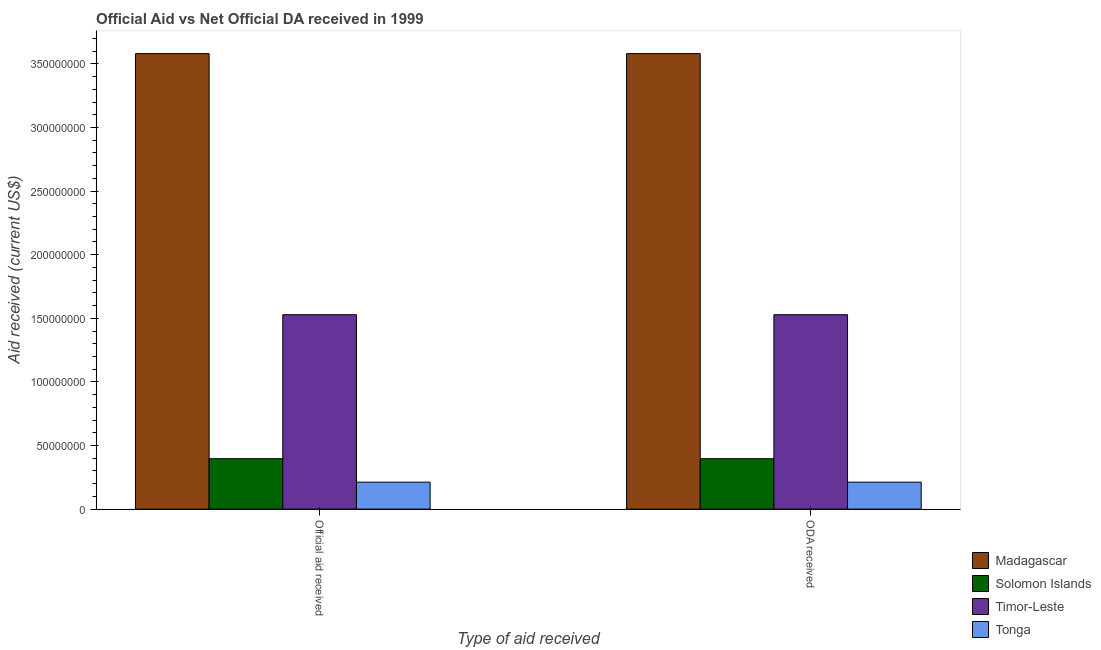How many bars are there on the 1st tick from the right?
Provide a short and direct response. 4. What is the label of the 1st group of bars from the left?
Your response must be concise. Official aid received. What is the oda received in Tonga?
Give a very brief answer. 2.12e+07. Across all countries, what is the maximum oda received?
Provide a succinct answer. 3.58e+08. Across all countries, what is the minimum oda received?
Ensure brevity in your answer.  2.12e+07. In which country was the official aid received maximum?
Your answer should be compact. Madagascar. In which country was the oda received minimum?
Offer a terse response. Tonga. What is the total oda received in the graph?
Ensure brevity in your answer.  5.72e+08. What is the difference between the official aid received in Madagascar and that in Tonga?
Your response must be concise. 3.37e+08. What is the difference between the official aid received in Tonga and the oda received in Timor-Leste?
Make the answer very short. -1.32e+08. What is the average official aid received per country?
Offer a very short reply. 1.43e+08. What is the ratio of the official aid received in Timor-Leste to that in Tonga?
Ensure brevity in your answer.  7.21. Is the official aid received in Solomon Islands less than that in Tonga?
Make the answer very short. No. What does the 2nd bar from the left in ODA received represents?
Make the answer very short. Solomon Islands. What does the 1st bar from the right in Official aid received represents?
Keep it short and to the point. Tonga. How many bars are there?
Make the answer very short. 8. What is the title of the graph?
Provide a succinct answer. Official Aid vs Net Official DA received in 1999 . Does "Azerbaijan" appear as one of the legend labels in the graph?
Keep it short and to the point. No. What is the label or title of the X-axis?
Keep it short and to the point. Type of aid received. What is the label or title of the Y-axis?
Offer a very short reply. Aid received (current US$). What is the Aid received (current US$) in Madagascar in Official aid received?
Provide a short and direct response. 3.58e+08. What is the Aid received (current US$) of Solomon Islands in Official aid received?
Give a very brief answer. 3.96e+07. What is the Aid received (current US$) in Timor-Leste in Official aid received?
Your answer should be compact. 1.53e+08. What is the Aid received (current US$) in Tonga in Official aid received?
Your response must be concise. 2.12e+07. What is the Aid received (current US$) of Madagascar in ODA received?
Provide a succinct answer. 3.58e+08. What is the Aid received (current US$) in Solomon Islands in ODA received?
Offer a terse response. 3.96e+07. What is the Aid received (current US$) of Timor-Leste in ODA received?
Provide a succinct answer. 1.53e+08. What is the Aid received (current US$) in Tonga in ODA received?
Ensure brevity in your answer.  2.12e+07. Across all Type of aid received, what is the maximum Aid received (current US$) of Madagascar?
Your answer should be compact. 3.58e+08. Across all Type of aid received, what is the maximum Aid received (current US$) in Solomon Islands?
Give a very brief answer. 3.96e+07. Across all Type of aid received, what is the maximum Aid received (current US$) of Timor-Leste?
Provide a short and direct response. 1.53e+08. Across all Type of aid received, what is the maximum Aid received (current US$) of Tonga?
Ensure brevity in your answer.  2.12e+07. Across all Type of aid received, what is the minimum Aid received (current US$) in Madagascar?
Provide a short and direct response. 3.58e+08. Across all Type of aid received, what is the minimum Aid received (current US$) of Solomon Islands?
Offer a very short reply. 3.96e+07. Across all Type of aid received, what is the minimum Aid received (current US$) in Timor-Leste?
Make the answer very short. 1.53e+08. Across all Type of aid received, what is the minimum Aid received (current US$) of Tonga?
Your answer should be compact. 2.12e+07. What is the total Aid received (current US$) of Madagascar in the graph?
Your answer should be compact. 7.16e+08. What is the total Aid received (current US$) in Solomon Islands in the graph?
Provide a succinct answer. 7.93e+07. What is the total Aid received (current US$) of Timor-Leste in the graph?
Give a very brief answer. 3.06e+08. What is the total Aid received (current US$) of Tonga in the graph?
Make the answer very short. 4.24e+07. What is the difference between the Aid received (current US$) in Madagascar in Official aid received and that in ODA received?
Give a very brief answer. 0. What is the difference between the Aid received (current US$) of Solomon Islands in Official aid received and that in ODA received?
Make the answer very short. 0. What is the difference between the Aid received (current US$) in Tonga in Official aid received and that in ODA received?
Give a very brief answer. 0. What is the difference between the Aid received (current US$) of Madagascar in Official aid received and the Aid received (current US$) of Solomon Islands in ODA received?
Give a very brief answer. 3.18e+08. What is the difference between the Aid received (current US$) in Madagascar in Official aid received and the Aid received (current US$) in Timor-Leste in ODA received?
Offer a very short reply. 2.05e+08. What is the difference between the Aid received (current US$) of Madagascar in Official aid received and the Aid received (current US$) of Tonga in ODA received?
Your response must be concise. 3.37e+08. What is the difference between the Aid received (current US$) of Solomon Islands in Official aid received and the Aid received (current US$) of Timor-Leste in ODA received?
Your answer should be very brief. -1.13e+08. What is the difference between the Aid received (current US$) of Solomon Islands in Official aid received and the Aid received (current US$) of Tonga in ODA received?
Keep it short and to the point. 1.84e+07. What is the difference between the Aid received (current US$) in Timor-Leste in Official aid received and the Aid received (current US$) in Tonga in ODA received?
Make the answer very short. 1.32e+08. What is the average Aid received (current US$) of Madagascar per Type of aid received?
Ensure brevity in your answer.  3.58e+08. What is the average Aid received (current US$) in Solomon Islands per Type of aid received?
Provide a succinct answer. 3.96e+07. What is the average Aid received (current US$) in Timor-Leste per Type of aid received?
Provide a succinct answer. 1.53e+08. What is the average Aid received (current US$) of Tonga per Type of aid received?
Make the answer very short. 2.12e+07. What is the difference between the Aid received (current US$) of Madagascar and Aid received (current US$) of Solomon Islands in Official aid received?
Ensure brevity in your answer.  3.18e+08. What is the difference between the Aid received (current US$) in Madagascar and Aid received (current US$) in Timor-Leste in Official aid received?
Your answer should be compact. 2.05e+08. What is the difference between the Aid received (current US$) of Madagascar and Aid received (current US$) of Tonga in Official aid received?
Your answer should be very brief. 3.37e+08. What is the difference between the Aid received (current US$) in Solomon Islands and Aid received (current US$) in Timor-Leste in Official aid received?
Your response must be concise. -1.13e+08. What is the difference between the Aid received (current US$) of Solomon Islands and Aid received (current US$) of Tonga in Official aid received?
Give a very brief answer. 1.84e+07. What is the difference between the Aid received (current US$) of Timor-Leste and Aid received (current US$) of Tonga in Official aid received?
Give a very brief answer. 1.32e+08. What is the difference between the Aid received (current US$) of Madagascar and Aid received (current US$) of Solomon Islands in ODA received?
Make the answer very short. 3.18e+08. What is the difference between the Aid received (current US$) in Madagascar and Aid received (current US$) in Timor-Leste in ODA received?
Ensure brevity in your answer.  2.05e+08. What is the difference between the Aid received (current US$) of Madagascar and Aid received (current US$) of Tonga in ODA received?
Your response must be concise. 3.37e+08. What is the difference between the Aid received (current US$) of Solomon Islands and Aid received (current US$) of Timor-Leste in ODA received?
Your answer should be compact. -1.13e+08. What is the difference between the Aid received (current US$) in Solomon Islands and Aid received (current US$) in Tonga in ODA received?
Offer a terse response. 1.84e+07. What is the difference between the Aid received (current US$) in Timor-Leste and Aid received (current US$) in Tonga in ODA received?
Offer a very short reply. 1.32e+08. What is the ratio of the Aid received (current US$) in Solomon Islands in Official aid received to that in ODA received?
Provide a succinct answer. 1. What is the difference between the highest and the second highest Aid received (current US$) of Madagascar?
Provide a succinct answer. 0. What is the difference between the highest and the second highest Aid received (current US$) of Solomon Islands?
Give a very brief answer. 0. What is the difference between the highest and the second highest Aid received (current US$) in Tonga?
Offer a very short reply. 0. What is the difference between the highest and the lowest Aid received (current US$) of Madagascar?
Your answer should be very brief. 0. What is the difference between the highest and the lowest Aid received (current US$) in Tonga?
Ensure brevity in your answer.  0. 